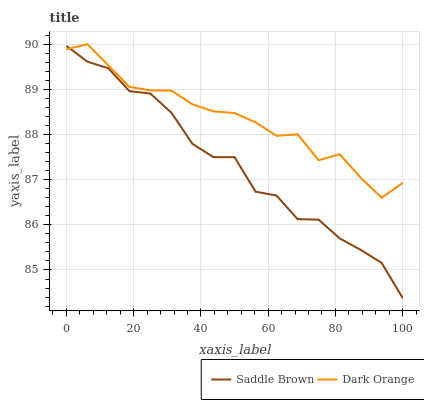Does Saddle Brown have the maximum area under the curve?
Answer yes or no. No. Is Saddle Brown the smoothest?
Answer yes or no. No. Does Saddle Brown have the highest value?
Answer yes or no. No. 